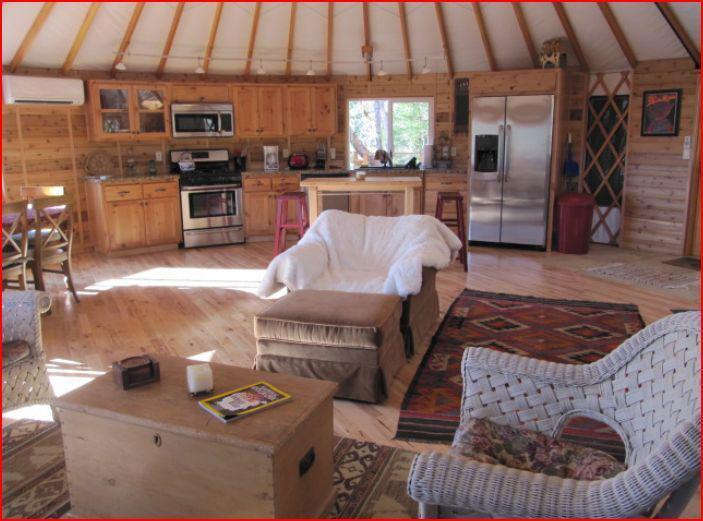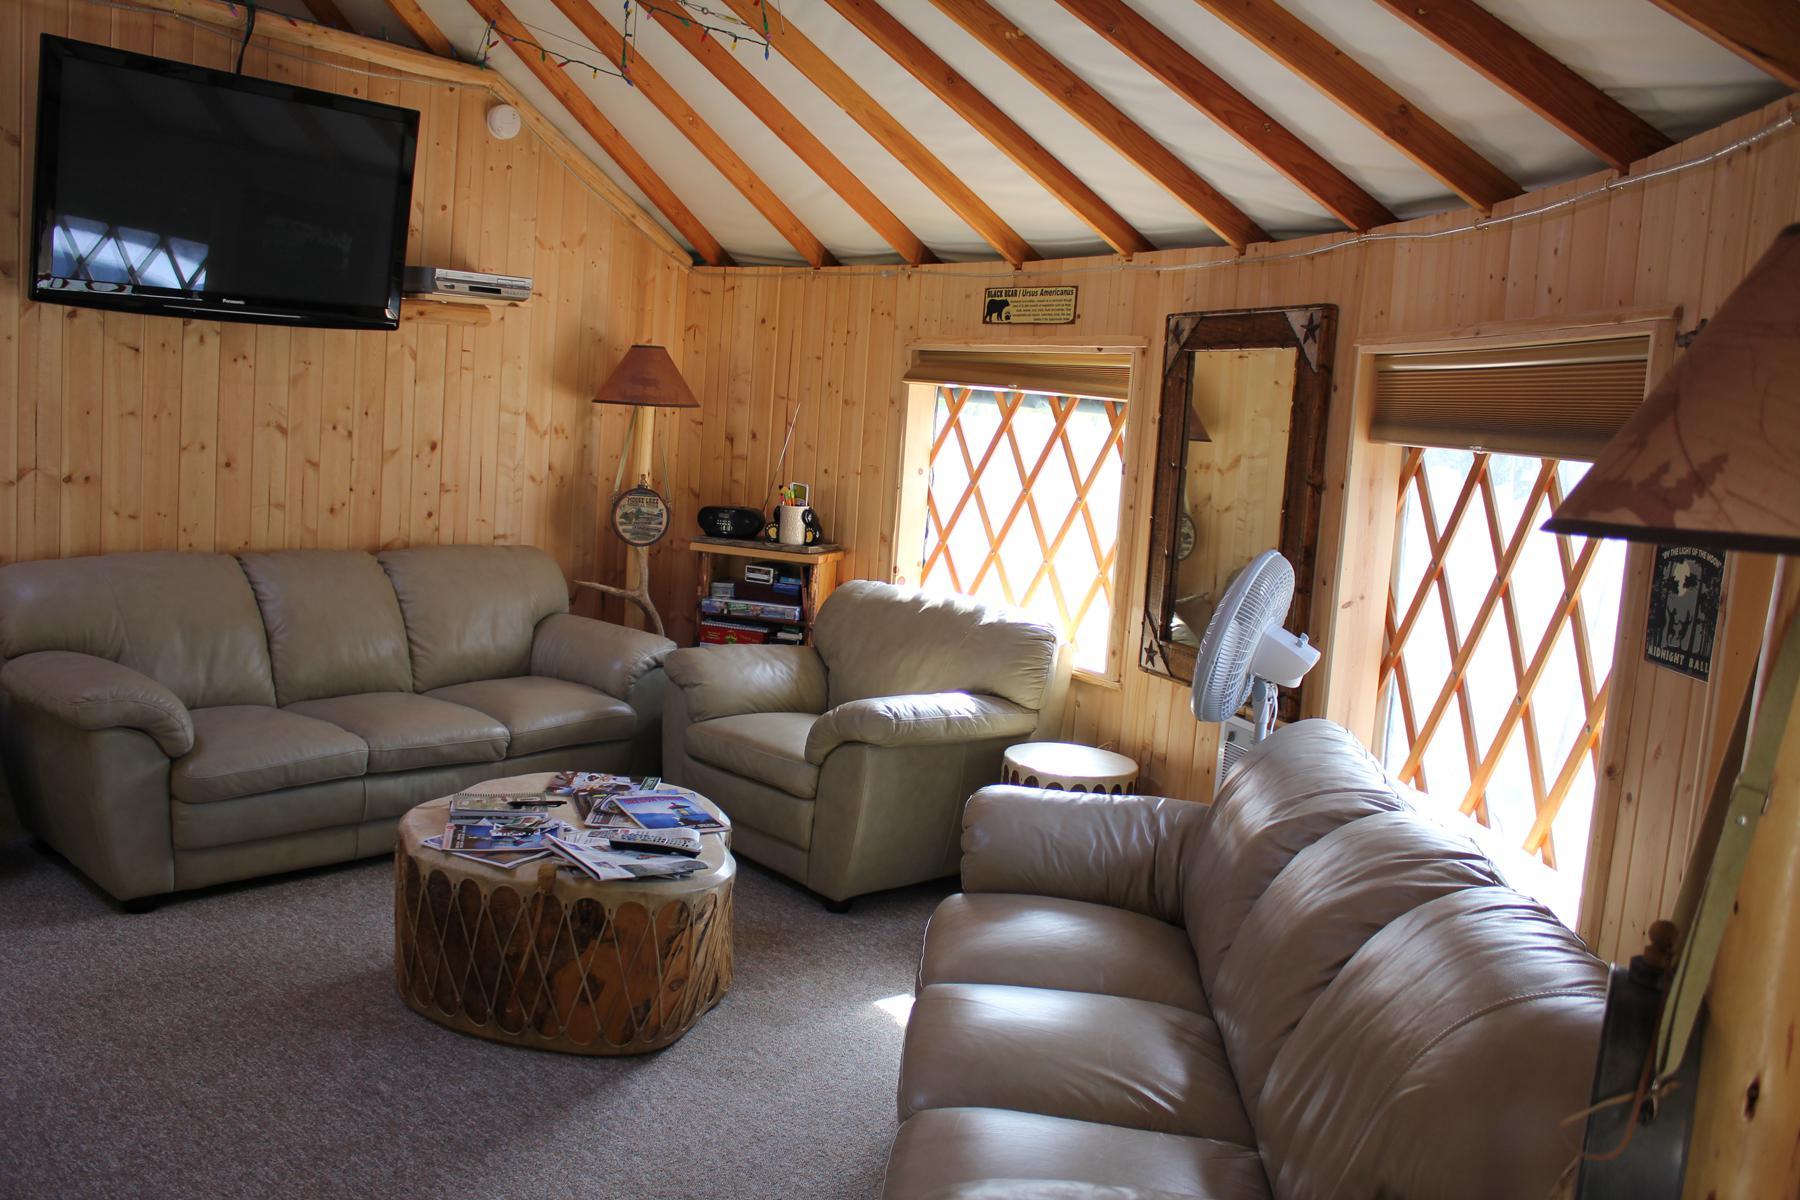The first image is the image on the left, the second image is the image on the right. Considering the images on both sides, is "At least one image shows a room with facing futon and angled bunk." valid? Answer yes or no. No. The first image is the image on the left, the second image is the image on the right. Assess this claim about the two images: "At least one image is of a sleeping area in a round house.". Correct or not? Answer yes or no. No. 